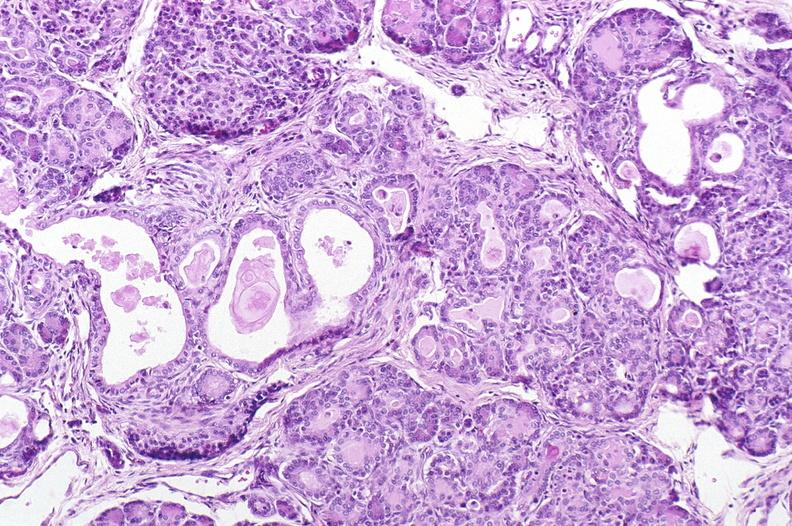s cut surface both testicles on normal and one quite small typical probably due to mumps present?
Answer the question using a single word or phrase. No 